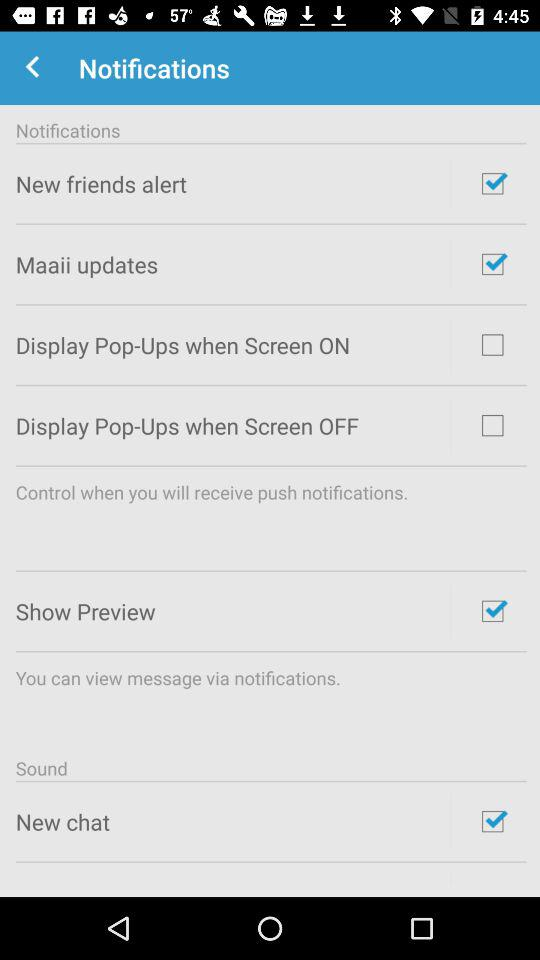What is the name of the application?
When the provided information is insufficient, respond with <no answer>. <no answer> 